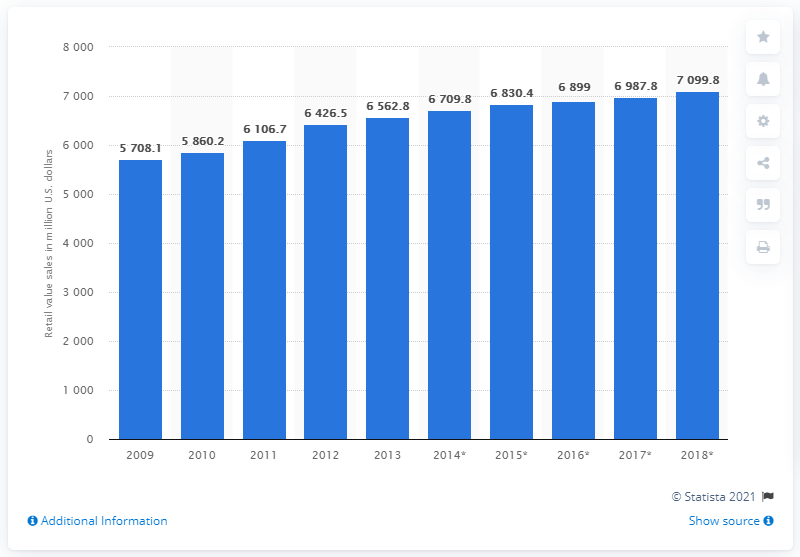Specify some key components in this picture. In 2013, the retail sales value of cheese in the UK was 6,562.8 million pounds. 